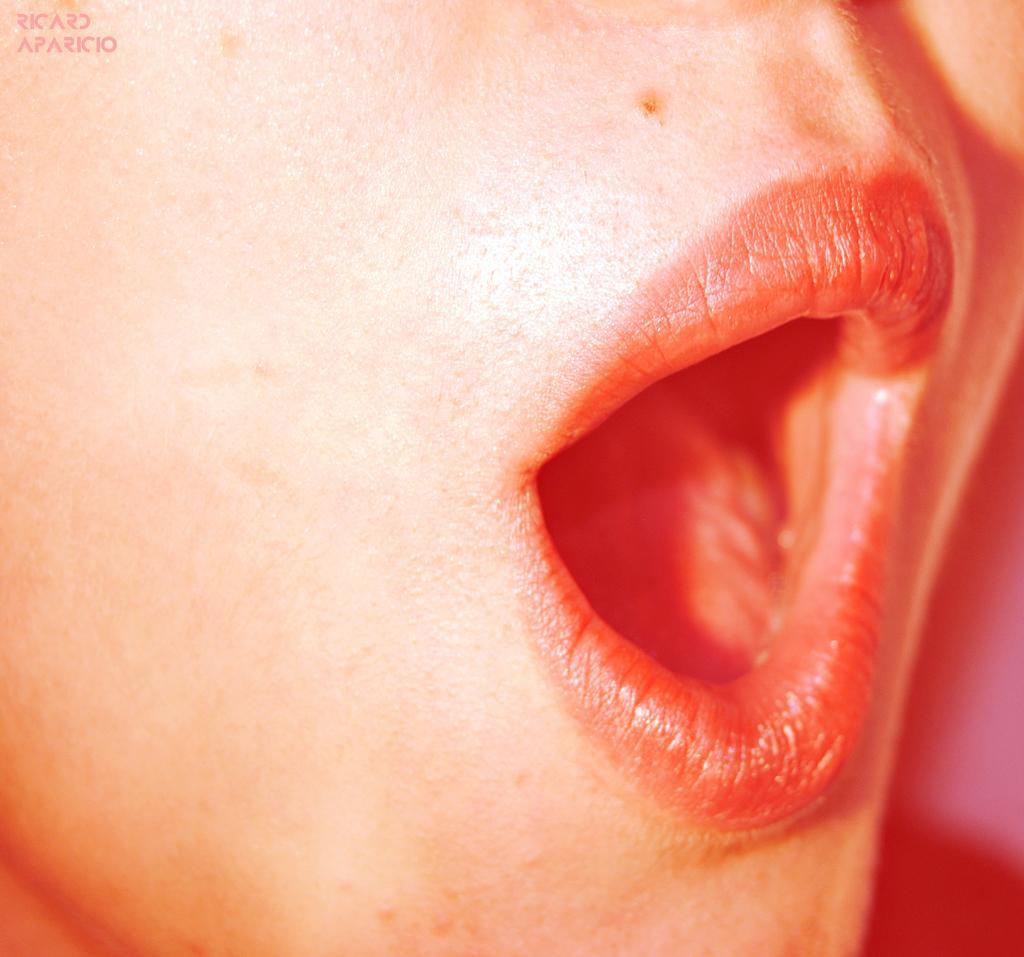In one or two sentences, can you explain what this image depicts? In this image there is person's face, there is the mouth, there are lips, there is a tongue, there is text towards the top of the image. 